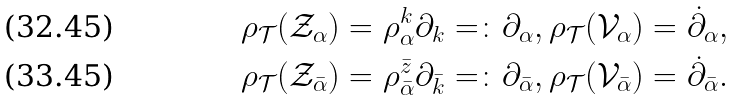Convert formula to latex. <formula><loc_0><loc_0><loc_500><loc_500>& \rho _ { \mathcal { T } } ( \mathcal { Z } _ { \alpha } ) = \rho ^ { k } _ { \alpha } \partial _ { k } = \colon \partial _ { \alpha } , \rho _ { \mathcal { T } } ( \mathcal { V } _ { \alpha } ) = \dot { \partial } _ { \alpha } , \\ & \rho _ { \mathcal { T } } ( \mathcal { Z } _ { \bar { \alpha } } ) = \rho ^ { \bar { z } } _ { \bar { \alpha } } \partial _ { \bar { k } } = \colon \partial _ { \bar { \alpha } } , \rho _ { \mathcal { T } } ( \mathcal { V } _ { \bar { \alpha } } ) = \dot { \partial } _ { \bar { \alpha } } .</formula> 